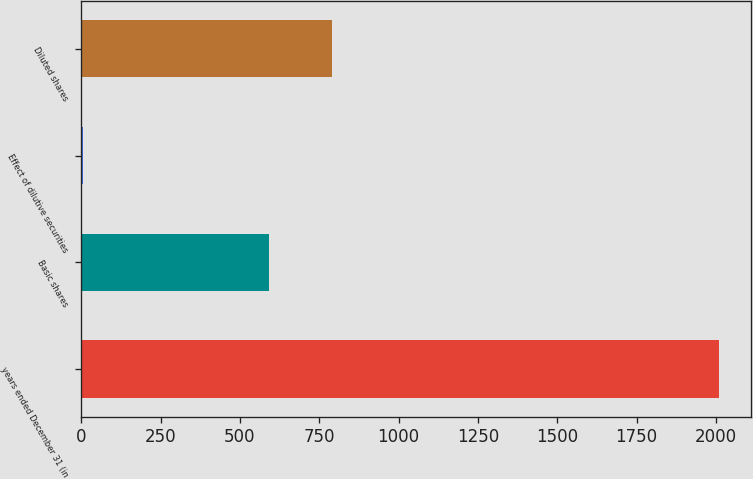<chart> <loc_0><loc_0><loc_500><loc_500><bar_chart><fcel>years ended December 31 (in<fcel>Basic shares<fcel>Effect of dilutive securities<fcel>Diluted shares<nl><fcel>2010<fcel>590<fcel>4<fcel>790.6<nl></chart> 